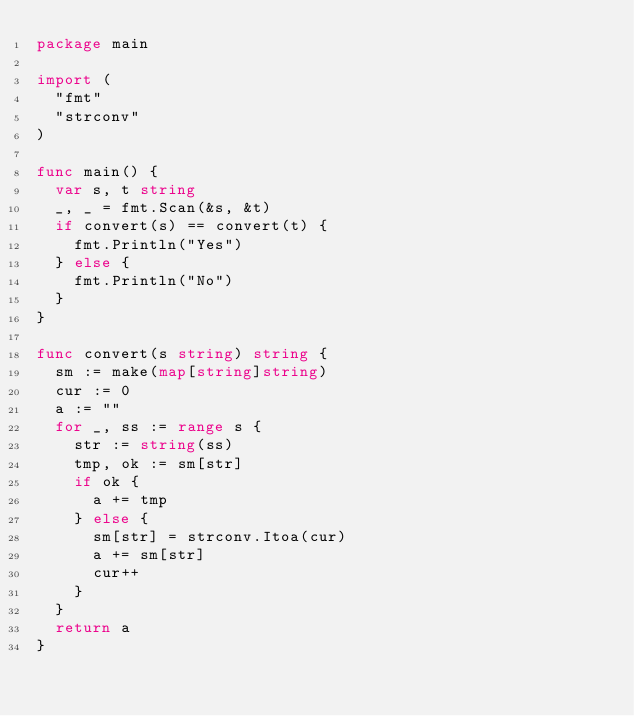Convert code to text. <code><loc_0><loc_0><loc_500><loc_500><_Go_>package main

import (
	"fmt"
	"strconv"
)

func main() {
	var s, t string
	_, _ = fmt.Scan(&s, &t)
	if convert(s) == convert(t) {
		fmt.Println("Yes")
	} else {
		fmt.Println("No")
	}
}

func convert(s string) string {
	sm := make(map[string]string)
	cur := 0
	a := ""
	for _, ss := range s {
		str := string(ss)
		tmp, ok := sm[str]
		if ok {
			a += tmp
		} else {
			sm[str] = strconv.Itoa(cur)
			a += sm[str]
			cur++
		}
	}
	return a
}</code> 